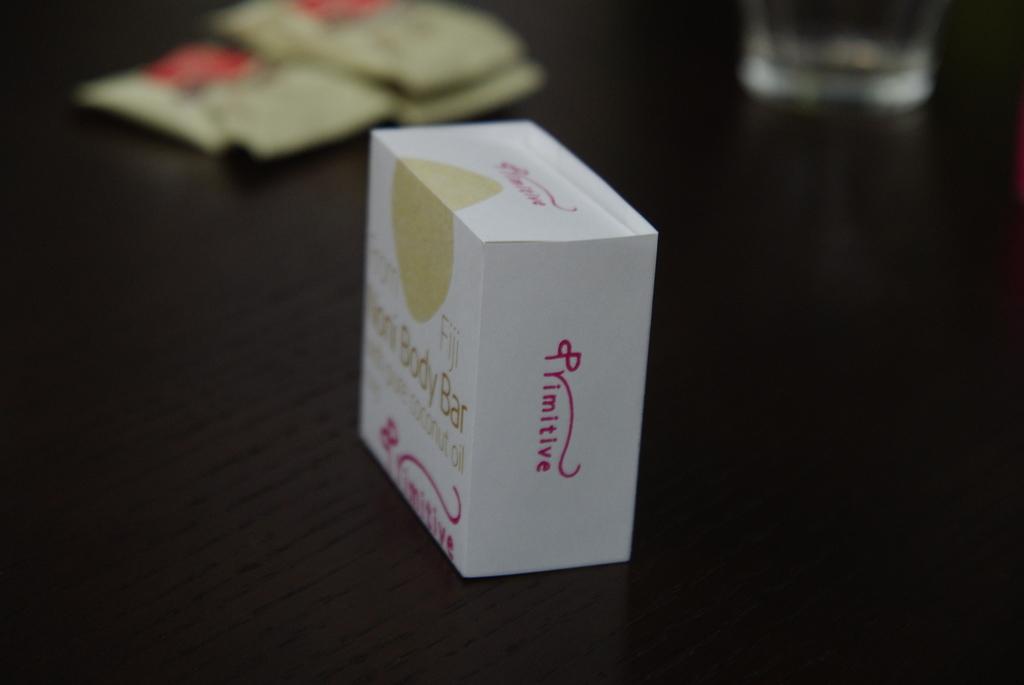What company made this box?
Your answer should be compact. Primitive. What is inside the box?
Your answer should be very brief. Body bar. 